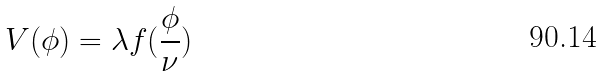Convert formula to latex. <formula><loc_0><loc_0><loc_500><loc_500>V ( \phi ) = \lambda f ( \frac { \phi } { \nu } )</formula> 